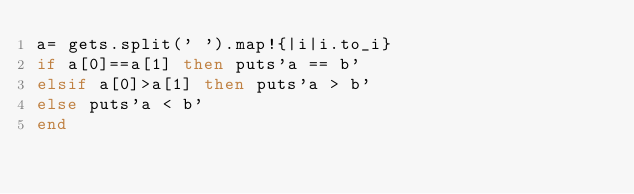Convert code to text. <code><loc_0><loc_0><loc_500><loc_500><_Ruby_>a= gets.split(' ').map!{|i|i.to_i}
if a[0]==a[1] then puts'a == b'
elsif a[0]>a[1] then puts'a > b'
else puts'a < b'
end</code> 